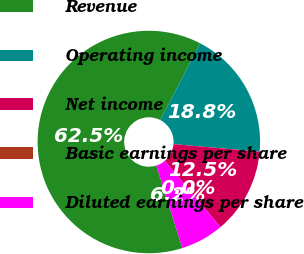<chart> <loc_0><loc_0><loc_500><loc_500><pie_chart><fcel>Revenue<fcel>Operating income<fcel>Net income<fcel>Basic earnings per share<fcel>Diluted earnings per share<nl><fcel>62.5%<fcel>18.75%<fcel>12.5%<fcel>0.0%<fcel>6.25%<nl></chart> 